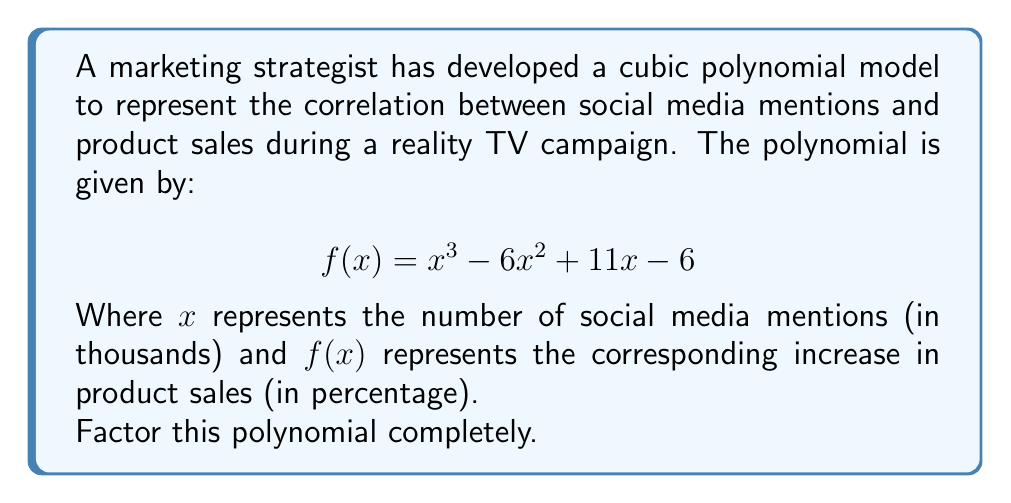Solve this math problem. To factor this cubic polynomial, we'll follow these steps:

1) First, let's check if there are any rational roots using the rational root theorem. The possible rational roots are the factors of the constant term: ±1, ±2, ±3, ±6.

2) By testing these values, we find that $f(1) = 0$. This means $(x-1)$ is a factor.

3) We can use polynomial long division to divide $f(x)$ by $(x-1)$:

   $$\frac{x^3 - 6x^2 + 11x - 6}{x-1} = x^2 - 5x + 6$$

4) So now we have: $f(x) = (x-1)(x^2 - 5x + 6)$

5) The quadratic factor $x^2 - 5x + 6$ can be factored further:
   
   $x^2 - 5x + 6 = (x-2)(x-3)$

6) Combining all factors, we get the complete factorization:

   $f(x) = (x-1)(x-2)(x-3)$

This factorization reveals that the polynomial has three real roots: 1, 2, and 3, which correspond to 1000, 2000, and 3000 social media mentions respectively.
Answer: $f(x) = (x-1)(x-2)(x-3)$ 